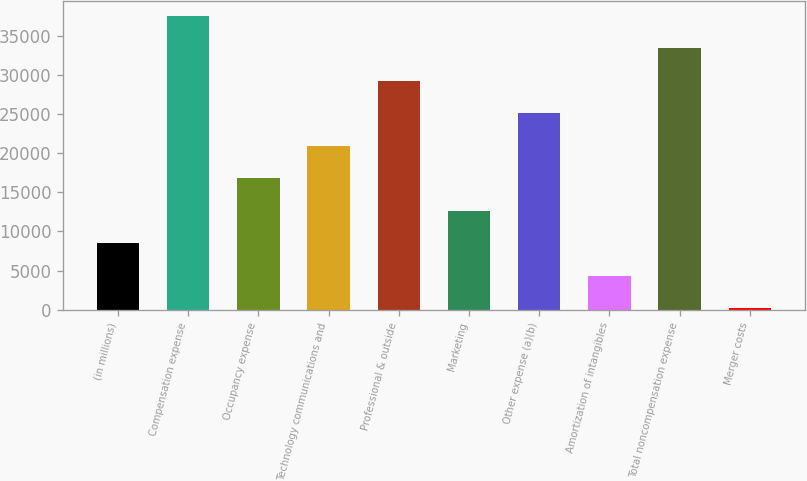<chart> <loc_0><loc_0><loc_500><loc_500><bar_chart><fcel>(in millions)<fcel>Compensation expense<fcel>Occupancy expense<fcel>Technology communications and<fcel>Professional & outside<fcel>Marketing<fcel>Other expense (a)(b)<fcel>Amortization of intangibles<fcel>Total noncompensation expense<fcel>Merger costs<nl><fcel>8507.8<fcel>37553.6<fcel>16806.6<fcel>20956<fcel>29254.8<fcel>12657.2<fcel>25105.4<fcel>4358.4<fcel>33404.2<fcel>209<nl></chart> 